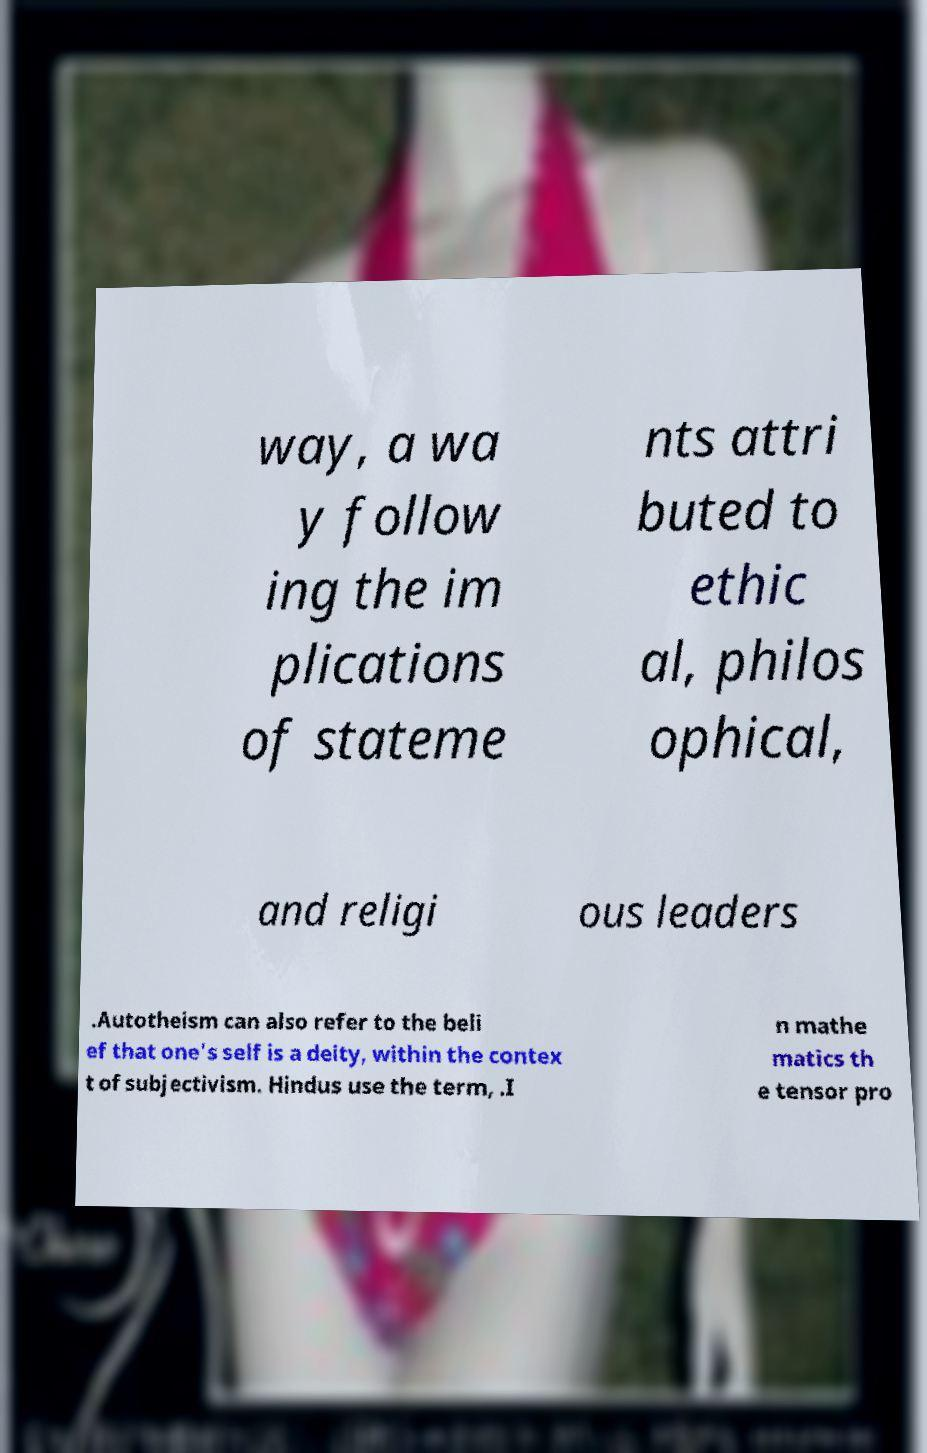There's text embedded in this image that I need extracted. Can you transcribe it verbatim? way, a wa y follow ing the im plications of stateme nts attri buted to ethic al, philos ophical, and religi ous leaders .Autotheism can also refer to the beli ef that one's self is a deity, within the contex t of subjectivism. Hindus use the term, .I n mathe matics th e tensor pro 